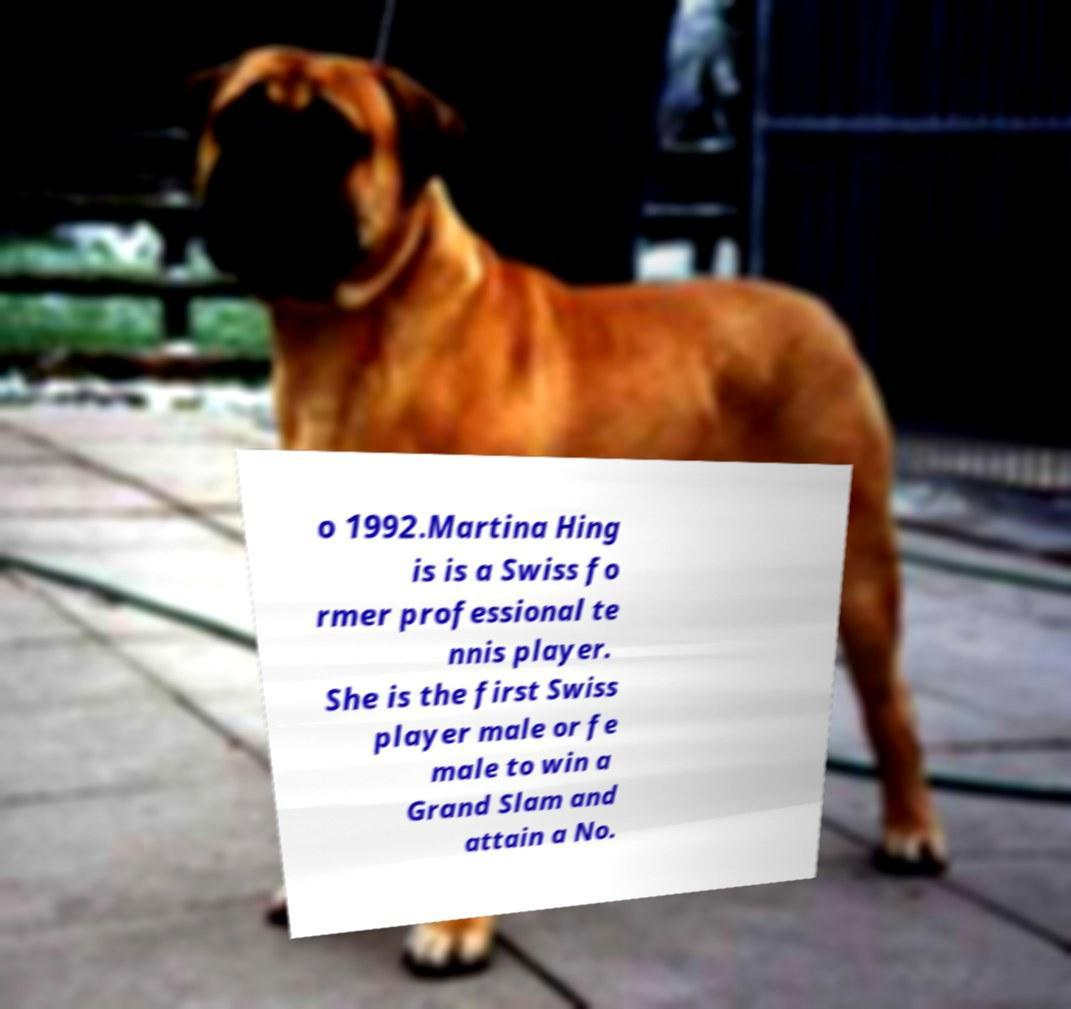There's text embedded in this image that I need extracted. Can you transcribe it verbatim? o 1992.Martina Hing is is a Swiss fo rmer professional te nnis player. She is the first Swiss player male or fe male to win a Grand Slam and attain a No. 